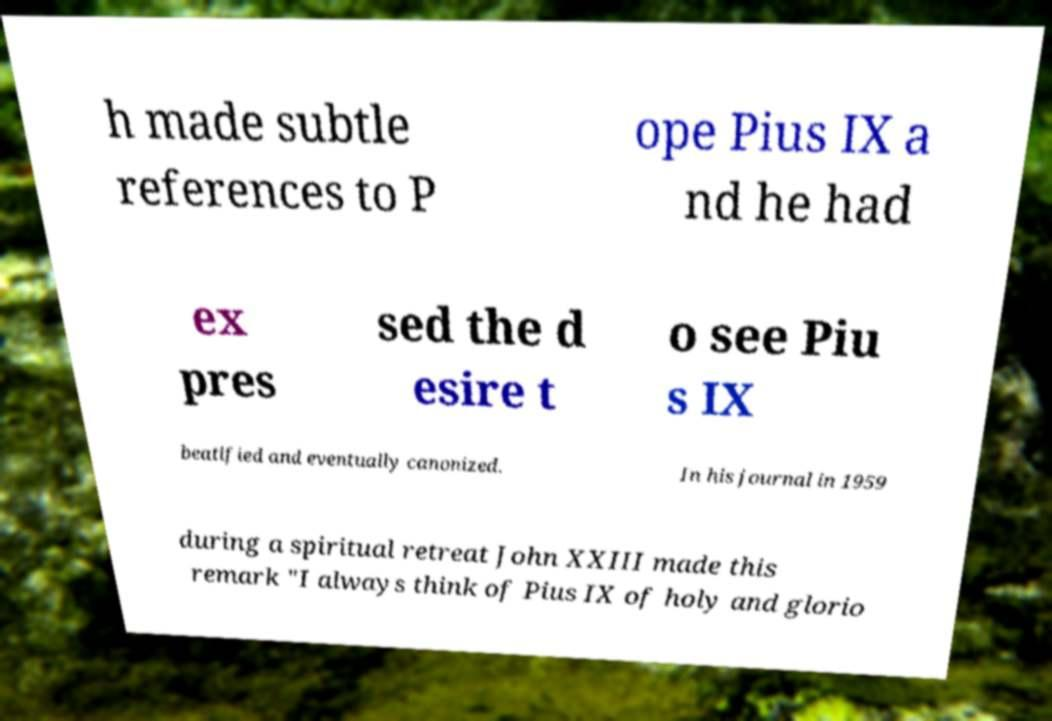Could you assist in decoding the text presented in this image and type it out clearly? h made subtle references to P ope Pius IX a nd he had ex pres sed the d esire t o see Piu s IX beatified and eventually canonized. In his journal in 1959 during a spiritual retreat John XXIII made this remark "I always think of Pius IX of holy and glorio 